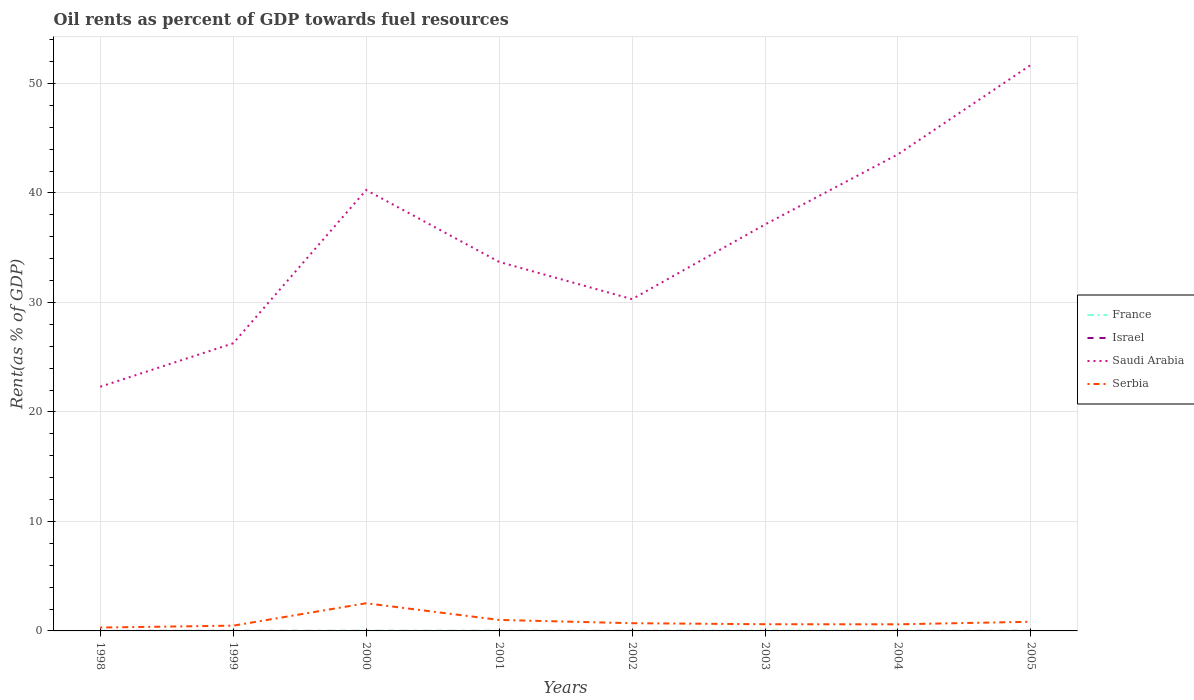Does the line corresponding to Saudi Arabia intersect with the line corresponding to Serbia?
Keep it short and to the point. No. Is the number of lines equal to the number of legend labels?
Offer a very short reply. Yes. Across all years, what is the maximum oil rent in France?
Keep it short and to the point. 0.01. In which year was the oil rent in Israel maximum?
Offer a very short reply. 2003. What is the total oil rent in Serbia in the graph?
Your answer should be compact. -0.22. What is the difference between the highest and the second highest oil rent in Serbia?
Provide a succinct answer. 2.22. Is the oil rent in Israel strictly greater than the oil rent in Saudi Arabia over the years?
Provide a short and direct response. Yes. How many years are there in the graph?
Ensure brevity in your answer.  8. Are the values on the major ticks of Y-axis written in scientific E-notation?
Provide a succinct answer. No. Does the graph contain any zero values?
Keep it short and to the point. No. Does the graph contain grids?
Offer a terse response. Yes. What is the title of the graph?
Provide a succinct answer. Oil rents as percent of GDP towards fuel resources. What is the label or title of the Y-axis?
Give a very brief answer. Rent(as % of GDP). What is the Rent(as % of GDP) in France in 1998?
Offer a terse response. 0.01. What is the Rent(as % of GDP) of Israel in 1998?
Provide a succinct answer. 0. What is the Rent(as % of GDP) in Saudi Arabia in 1998?
Offer a terse response. 22.3. What is the Rent(as % of GDP) in Serbia in 1998?
Your answer should be very brief. 0.31. What is the Rent(as % of GDP) in France in 1999?
Make the answer very short. 0.01. What is the Rent(as % of GDP) of Israel in 1999?
Give a very brief answer. 0. What is the Rent(as % of GDP) in Saudi Arabia in 1999?
Keep it short and to the point. 26.27. What is the Rent(as % of GDP) of Serbia in 1999?
Offer a very short reply. 0.48. What is the Rent(as % of GDP) of France in 2000?
Offer a very short reply. 0.02. What is the Rent(as % of GDP) of Israel in 2000?
Provide a succinct answer. 0. What is the Rent(as % of GDP) of Saudi Arabia in 2000?
Offer a very short reply. 40.27. What is the Rent(as % of GDP) of Serbia in 2000?
Keep it short and to the point. 2.53. What is the Rent(as % of GDP) in France in 2001?
Offer a terse response. 0.01. What is the Rent(as % of GDP) of Israel in 2001?
Your response must be concise. 0. What is the Rent(as % of GDP) of Saudi Arabia in 2001?
Provide a short and direct response. 33.71. What is the Rent(as % of GDP) in Serbia in 2001?
Give a very brief answer. 1. What is the Rent(as % of GDP) of France in 2002?
Provide a short and direct response. 0.01. What is the Rent(as % of GDP) in Israel in 2002?
Provide a succinct answer. 0. What is the Rent(as % of GDP) in Saudi Arabia in 2002?
Offer a very short reply. 30.3. What is the Rent(as % of GDP) in Serbia in 2002?
Ensure brevity in your answer.  0.7. What is the Rent(as % of GDP) in France in 2003?
Offer a terse response. 0.01. What is the Rent(as % of GDP) of Israel in 2003?
Give a very brief answer. 0. What is the Rent(as % of GDP) in Saudi Arabia in 2003?
Offer a terse response. 37.12. What is the Rent(as % of GDP) of Serbia in 2003?
Provide a short and direct response. 0.61. What is the Rent(as % of GDP) in France in 2004?
Ensure brevity in your answer.  0.01. What is the Rent(as % of GDP) in Israel in 2004?
Offer a very short reply. 0. What is the Rent(as % of GDP) of Saudi Arabia in 2004?
Your answer should be very brief. 43.53. What is the Rent(as % of GDP) of Serbia in 2004?
Offer a very short reply. 0.6. What is the Rent(as % of GDP) in France in 2005?
Provide a short and direct response. 0.02. What is the Rent(as % of GDP) of Israel in 2005?
Your response must be concise. 0. What is the Rent(as % of GDP) in Saudi Arabia in 2005?
Make the answer very short. 51.7. What is the Rent(as % of GDP) of Serbia in 2005?
Make the answer very short. 0.84. Across all years, what is the maximum Rent(as % of GDP) in France?
Your response must be concise. 0.02. Across all years, what is the maximum Rent(as % of GDP) in Israel?
Your response must be concise. 0. Across all years, what is the maximum Rent(as % of GDP) of Saudi Arabia?
Ensure brevity in your answer.  51.7. Across all years, what is the maximum Rent(as % of GDP) in Serbia?
Your answer should be compact. 2.53. Across all years, what is the minimum Rent(as % of GDP) in France?
Your response must be concise. 0.01. Across all years, what is the minimum Rent(as % of GDP) in Israel?
Offer a terse response. 0. Across all years, what is the minimum Rent(as % of GDP) in Saudi Arabia?
Your answer should be compact. 22.3. Across all years, what is the minimum Rent(as % of GDP) in Serbia?
Offer a terse response. 0.31. What is the total Rent(as % of GDP) in France in the graph?
Your answer should be very brief. 0.1. What is the total Rent(as % of GDP) of Israel in the graph?
Your answer should be compact. 0.01. What is the total Rent(as % of GDP) of Saudi Arabia in the graph?
Keep it short and to the point. 285.22. What is the total Rent(as % of GDP) in Serbia in the graph?
Ensure brevity in your answer.  7.08. What is the difference between the Rent(as % of GDP) of France in 1998 and that in 1999?
Your answer should be very brief. -0. What is the difference between the Rent(as % of GDP) in Israel in 1998 and that in 1999?
Your response must be concise. -0. What is the difference between the Rent(as % of GDP) in Saudi Arabia in 1998 and that in 1999?
Give a very brief answer. -3.97. What is the difference between the Rent(as % of GDP) in Serbia in 1998 and that in 1999?
Your answer should be compact. -0.17. What is the difference between the Rent(as % of GDP) in France in 1998 and that in 2000?
Give a very brief answer. -0.01. What is the difference between the Rent(as % of GDP) in Israel in 1998 and that in 2000?
Offer a terse response. 0. What is the difference between the Rent(as % of GDP) in Saudi Arabia in 1998 and that in 2000?
Ensure brevity in your answer.  -17.97. What is the difference between the Rent(as % of GDP) in Serbia in 1998 and that in 2000?
Make the answer very short. -2.22. What is the difference between the Rent(as % of GDP) of France in 1998 and that in 2001?
Keep it short and to the point. -0.01. What is the difference between the Rent(as % of GDP) in Israel in 1998 and that in 2001?
Provide a succinct answer. 0. What is the difference between the Rent(as % of GDP) of Saudi Arabia in 1998 and that in 2001?
Offer a terse response. -11.4. What is the difference between the Rent(as % of GDP) in Serbia in 1998 and that in 2001?
Provide a short and direct response. -0.69. What is the difference between the Rent(as % of GDP) of France in 1998 and that in 2002?
Make the answer very short. -0.01. What is the difference between the Rent(as % of GDP) of Israel in 1998 and that in 2002?
Offer a terse response. -0. What is the difference between the Rent(as % of GDP) of Saudi Arabia in 1998 and that in 2002?
Provide a succinct answer. -8. What is the difference between the Rent(as % of GDP) in Serbia in 1998 and that in 2002?
Keep it short and to the point. -0.39. What is the difference between the Rent(as % of GDP) of France in 1998 and that in 2003?
Offer a terse response. -0. What is the difference between the Rent(as % of GDP) in Israel in 1998 and that in 2003?
Your response must be concise. 0. What is the difference between the Rent(as % of GDP) in Saudi Arabia in 1998 and that in 2003?
Make the answer very short. -14.82. What is the difference between the Rent(as % of GDP) of Serbia in 1998 and that in 2003?
Your answer should be compact. -0.3. What is the difference between the Rent(as % of GDP) of France in 1998 and that in 2004?
Ensure brevity in your answer.  -0.01. What is the difference between the Rent(as % of GDP) in Israel in 1998 and that in 2004?
Give a very brief answer. -0. What is the difference between the Rent(as % of GDP) in Saudi Arabia in 1998 and that in 2004?
Offer a very short reply. -21.23. What is the difference between the Rent(as % of GDP) in Serbia in 1998 and that in 2004?
Keep it short and to the point. -0.29. What is the difference between the Rent(as % of GDP) in France in 1998 and that in 2005?
Provide a short and direct response. -0.01. What is the difference between the Rent(as % of GDP) of Israel in 1998 and that in 2005?
Give a very brief answer. -0. What is the difference between the Rent(as % of GDP) in Saudi Arabia in 1998 and that in 2005?
Keep it short and to the point. -29.4. What is the difference between the Rent(as % of GDP) in Serbia in 1998 and that in 2005?
Make the answer very short. -0.53. What is the difference between the Rent(as % of GDP) of France in 1999 and that in 2000?
Provide a succinct answer. -0.01. What is the difference between the Rent(as % of GDP) in Israel in 1999 and that in 2000?
Offer a terse response. 0. What is the difference between the Rent(as % of GDP) in Saudi Arabia in 1999 and that in 2000?
Make the answer very short. -14. What is the difference between the Rent(as % of GDP) of Serbia in 1999 and that in 2000?
Provide a succinct answer. -2.05. What is the difference between the Rent(as % of GDP) in France in 1999 and that in 2001?
Your answer should be compact. -0. What is the difference between the Rent(as % of GDP) of Israel in 1999 and that in 2001?
Your answer should be compact. 0. What is the difference between the Rent(as % of GDP) of Saudi Arabia in 1999 and that in 2001?
Keep it short and to the point. -7.44. What is the difference between the Rent(as % of GDP) of Serbia in 1999 and that in 2001?
Your answer should be compact. -0.52. What is the difference between the Rent(as % of GDP) in France in 1999 and that in 2002?
Give a very brief answer. -0. What is the difference between the Rent(as % of GDP) of Saudi Arabia in 1999 and that in 2002?
Your answer should be very brief. -4.03. What is the difference between the Rent(as % of GDP) in Serbia in 1999 and that in 2002?
Your response must be concise. -0.22. What is the difference between the Rent(as % of GDP) of France in 1999 and that in 2003?
Your answer should be compact. -0. What is the difference between the Rent(as % of GDP) in Israel in 1999 and that in 2003?
Your response must be concise. 0. What is the difference between the Rent(as % of GDP) of Saudi Arabia in 1999 and that in 2003?
Ensure brevity in your answer.  -10.85. What is the difference between the Rent(as % of GDP) of Serbia in 1999 and that in 2003?
Ensure brevity in your answer.  -0.13. What is the difference between the Rent(as % of GDP) in France in 1999 and that in 2004?
Provide a succinct answer. -0. What is the difference between the Rent(as % of GDP) in Saudi Arabia in 1999 and that in 2004?
Keep it short and to the point. -17.26. What is the difference between the Rent(as % of GDP) of Serbia in 1999 and that in 2004?
Ensure brevity in your answer.  -0.12. What is the difference between the Rent(as % of GDP) in France in 1999 and that in 2005?
Provide a succinct answer. -0.01. What is the difference between the Rent(as % of GDP) of Israel in 1999 and that in 2005?
Provide a succinct answer. -0. What is the difference between the Rent(as % of GDP) in Saudi Arabia in 1999 and that in 2005?
Provide a succinct answer. -25.43. What is the difference between the Rent(as % of GDP) of Serbia in 1999 and that in 2005?
Keep it short and to the point. -0.36. What is the difference between the Rent(as % of GDP) in France in 2000 and that in 2001?
Offer a terse response. 0. What is the difference between the Rent(as % of GDP) in Israel in 2000 and that in 2001?
Your answer should be very brief. 0. What is the difference between the Rent(as % of GDP) of Saudi Arabia in 2000 and that in 2001?
Ensure brevity in your answer.  6.56. What is the difference between the Rent(as % of GDP) in Serbia in 2000 and that in 2001?
Your response must be concise. 1.52. What is the difference between the Rent(as % of GDP) of France in 2000 and that in 2002?
Give a very brief answer. 0.01. What is the difference between the Rent(as % of GDP) in Israel in 2000 and that in 2002?
Ensure brevity in your answer.  -0. What is the difference between the Rent(as % of GDP) of Saudi Arabia in 2000 and that in 2002?
Offer a terse response. 9.97. What is the difference between the Rent(as % of GDP) of Serbia in 2000 and that in 2002?
Your answer should be very brief. 1.82. What is the difference between the Rent(as % of GDP) in France in 2000 and that in 2003?
Give a very brief answer. 0.01. What is the difference between the Rent(as % of GDP) in Saudi Arabia in 2000 and that in 2003?
Your answer should be very brief. 3.15. What is the difference between the Rent(as % of GDP) of Serbia in 2000 and that in 2003?
Ensure brevity in your answer.  1.92. What is the difference between the Rent(as % of GDP) of France in 2000 and that in 2004?
Your answer should be compact. 0.01. What is the difference between the Rent(as % of GDP) in Israel in 2000 and that in 2004?
Your response must be concise. -0. What is the difference between the Rent(as % of GDP) of Saudi Arabia in 2000 and that in 2004?
Provide a short and direct response. -3.26. What is the difference between the Rent(as % of GDP) in Serbia in 2000 and that in 2004?
Your answer should be very brief. 1.92. What is the difference between the Rent(as % of GDP) of France in 2000 and that in 2005?
Provide a succinct answer. 0. What is the difference between the Rent(as % of GDP) of Israel in 2000 and that in 2005?
Your answer should be compact. -0. What is the difference between the Rent(as % of GDP) of Saudi Arabia in 2000 and that in 2005?
Provide a short and direct response. -11.43. What is the difference between the Rent(as % of GDP) in Serbia in 2000 and that in 2005?
Give a very brief answer. 1.69. What is the difference between the Rent(as % of GDP) in France in 2001 and that in 2002?
Offer a terse response. 0. What is the difference between the Rent(as % of GDP) in Israel in 2001 and that in 2002?
Keep it short and to the point. -0. What is the difference between the Rent(as % of GDP) of Saudi Arabia in 2001 and that in 2002?
Offer a very short reply. 3.4. What is the difference between the Rent(as % of GDP) of Serbia in 2001 and that in 2002?
Make the answer very short. 0.3. What is the difference between the Rent(as % of GDP) of France in 2001 and that in 2003?
Offer a very short reply. 0. What is the difference between the Rent(as % of GDP) of Israel in 2001 and that in 2003?
Offer a very short reply. 0. What is the difference between the Rent(as % of GDP) of Saudi Arabia in 2001 and that in 2003?
Keep it short and to the point. -3.42. What is the difference between the Rent(as % of GDP) in Serbia in 2001 and that in 2003?
Provide a succinct answer. 0.39. What is the difference between the Rent(as % of GDP) of France in 2001 and that in 2004?
Make the answer very short. 0. What is the difference between the Rent(as % of GDP) in Israel in 2001 and that in 2004?
Your answer should be very brief. -0. What is the difference between the Rent(as % of GDP) in Saudi Arabia in 2001 and that in 2004?
Make the answer very short. -9.83. What is the difference between the Rent(as % of GDP) in Serbia in 2001 and that in 2004?
Give a very brief answer. 0.4. What is the difference between the Rent(as % of GDP) in France in 2001 and that in 2005?
Your answer should be compact. -0. What is the difference between the Rent(as % of GDP) of Israel in 2001 and that in 2005?
Provide a succinct answer. -0. What is the difference between the Rent(as % of GDP) of Saudi Arabia in 2001 and that in 2005?
Provide a short and direct response. -17.99. What is the difference between the Rent(as % of GDP) of Serbia in 2001 and that in 2005?
Your answer should be very brief. 0.17. What is the difference between the Rent(as % of GDP) in France in 2002 and that in 2003?
Give a very brief answer. 0. What is the difference between the Rent(as % of GDP) in Israel in 2002 and that in 2003?
Provide a short and direct response. 0. What is the difference between the Rent(as % of GDP) in Saudi Arabia in 2002 and that in 2003?
Your answer should be very brief. -6.82. What is the difference between the Rent(as % of GDP) of Serbia in 2002 and that in 2003?
Give a very brief answer. 0.09. What is the difference between the Rent(as % of GDP) of France in 2002 and that in 2004?
Keep it short and to the point. -0. What is the difference between the Rent(as % of GDP) in Israel in 2002 and that in 2004?
Keep it short and to the point. -0. What is the difference between the Rent(as % of GDP) in Saudi Arabia in 2002 and that in 2004?
Your response must be concise. -13.23. What is the difference between the Rent(as % of GDP) in Serbia in 2002 and that in 2004?
Offer a terse response. 0.1. What is the difference between the Rent(as % of GDP) in France in 2002 and that in 2005?
Provide a succinct answer. -0. What is the difference between the Rent(as % of GDP) in Israel in 2002 and that in 2005?
Give a very brief answer. -0. What is the difference between the Rent(as % of GDP) of Saudi Arabia in 2002 and that in 2005?
Give a very brief answer. -21.4. What is the difference between the Rent(as % of GDP) in Serbia in 2002 and that in 2005?
Your response must be concise. -0.13. What is the difference between the Rent(as % of GDP) in France in 2003 and that in 2004?
Make the answer very short. -0. What is the difference between the Rent(as % of GDP) of Israel in 2003 and that in 2004?
Keep it short and to the point. -0. What is the difference between the Rent(as % of GDP) in Saudi Arabia in 2003 and that in 2004?
Provide a short and direct response. -6.41. What is the difference between the Rent(as % of GDP) of Serbia in 2003 and that in 2004?
Your answer should be compact. 0.01. What is the difference between the Rent(as % of GDP) in France in 2003 and that in 2005?
Offer a very short reply. -0.01. What is the difference between the Rent(as % of GDP) of Israel in 2003 and that in 2005?
Ensure brevity in your answer.  -0. What is the difference between the Rent(as % of GDP) in Saudi Arabia in 2003 and that in 2005?
Ensure brevity in your answer.  -14.58. What is the difference between the Rent(as % of GDP) of Serbia in 2003 and that in 2005?
Provide a succinct answer. -0.22. What is the difference between the Rent(as % of GDP) in France in 2004 and that in 2005?
Provide a succinct answer. -0. What is the difference between the Rent(as % of GDP) of Israel in 2004 and that in 2005?
Offer a very short reply. -0. What is the difference between the Rent(as % of GDP) of Saudi Arabia in 2004 and that in 2005?
Keep it short and to the point. -8.17. What is the difference between the Rent(as % of GDP) in Serbia in 2004 and that in 2005?
Your response must be concise. -0.23. What is the difference between the Rent(as % of GDP) in France in 1998 and the Rent(as % of GDP) in Israel in 1999?
Give a very brief answer. 0.01. What is the difference between the Rent(as % of GDP) of France in 1998 and the Rent(as % of GDP) of Saudi Arabia in 1999?
Offer a terse response. -26.26. What is the difference between the Rent(as % of GDP) in France in 1998 and the Rent(as % of GDP) in Serbia in 1999?
Offer a terse response. -0.47. What is the difference between the Rent(as % of GDP) of Israel in 1998 and the Rent(as % of GDP) of Saudi Arabia in 1999?
Offer a terse response. -26.27. What is the difference between the Rent(as % of GDP) in Israel in 1998 and the Rent(as % of GDP) in Serbia in 1999?
Ensure brevity in your answer.  -0.48. What is the difference between the Rent(as % of GDP) of Saudi Arabia in 1998 and the Rent(as % of GDP) of Serbia in 1999?
Ensure brevity in your answer.  21.82. What is the difference between the Rent(as % of GDP) in France in 1998 and the Rent(as % of GDP) in Israel in 2000?
Offer a terse response. 0.01. What is the difference between the Rent(as % of GDP) of France in 1998 and the Rent(as % of GDP) of Saudi Arabia in 2000?
Provide a short and direct response. -40.27. What is the difference between the Rent(as % of GDP) of France in 1998 and the Rent(as % of GDP) of Serbia in 2000?
Your answer should be very brief. -2.52. What is the difference between the Rent(as % of GDP) in Israel in 1998 and the Rent(as % of GDP) in Saudi Arabia in 2000?
Provide a succinct answer. -40.27. What is the difference between the Rent(as % of GDP) in Israel in 1998 and the Rent(as % of GDP) in Serbia in 2000?
Offer a very short reply. -2.53. What is the difference between the Rent(as % of GDP) of Saudi Arabia in 1998 and the Rent(as % of GDP) of Serbia in 2000?
Offer a very short reply. 19.78. What is the difference between the Rent(as % of GDP) of France in 1998 and the Rent(as % of GDP) of Israel in 2001?
Ensure brevity in your answer.  0.01. What is the difference between the Rent(as % of GDP) in France in 1998 and the Rent(as % of GDP) in Saudi Arabia in 2001?
Provide a short and direct response. -33.7. What is the difference between the Rent(as % of GDP) of France in 1998 and the Rent(as % of GDP) of Serbia in 2001?
Offer a very short reply. -1. What is the difference between the Rent(as % of GDP) in Israel in 1998 and the Rent(as % of GDP) in Saudi Arabia in 2001?
Your answer should be very brief. -33.71. What is the difference between the Rent(as % of GDP) of Israel in 1998 and the Rent(as % of GDP) of Serbia in 2001?
Your answer should be compact. -1. What is the difference between the Rent(as % of GDP) in Saudi Arabia in 1998 and the Rent(as % of GDP) in Serbia in 2001?
Provide a short and direct response. 21.3. What is the difference between the Rent(as % of GDP) in France in 1998 and the Rent(as % of GDP) in Israel in 2002?
Your response must be concise. 0.01. What is the difference between the Rent(as % of GDP) of France in 1998 and the Rent(as % of GDP) of Saudi Arabia in 2002?
Offer a very short reply. -30.3. What is the difference between the Rent(as % of GDP) of France in 1998 and the Rent(as % of GDP) of Serbia in 2002?
Make the answer very short. -0.7. What is the difference between the Rent(as % of GDP) in Israel in 1998 and the Rent(as % of GDP) in Saudi Arabia in 2002?
Give a very brief answer. -30.3. What is the difference between the Rent(as % of GDP) in Israel in 1998 and the Rent(as % of GDP) in Serbia in 2002?
Keep it short and to the point. -0.7. What is the difference between the Rent(as % of GDP) in Saudi Arabia in 1998 and the Rent(as % of GDP) in Serbia in 2002?
Keep it short and to the point. 21.6. What is the difference between the Rent(as % of GDP) of France in 1998 and the Rent(as % of GDP) of Israel in 2003?
Your answer should be very brief. 0.01. What is the difference between the Rent(as % of GDP) in France in 1998 and the Rent(as % of GDP) in Saudi Arabia in 2003?
Ensure brevity in your answer.  -37.12. What is the difference between the Rent(as % of GDP) of France in 1998 and the Rent(as % of GDP) of Serbia in 2003?
Offer a terse response. -0.6. What is the difference between the Rent(as % of GDP) in Israel in 1998 and the Rent(as % of GDP) in Saudi Arabia in 2003?
Your answer should be very brief. -37.12. What is the difference between the Rent(as % of GDP) of Israel in 1998 and the Rent(as % of GDP) of Serbia in 2003?
Make the answer very short. -0.61. What is the difference between the Rent(as % of GDP) of Saudi Arabia in 1998 and the Rent(as % of GDP) of Serbia in 2003?
Offer a terse response. 21.69. What is the difference between the Rent(as % of GDP) of France in 1998 and the Rent(as % of GDP) of Israel in 2004?
Keep it short and to the point. 0.01. What is the difference between the Rent(as % of GDP) in France in 1998 and the Rent(as % of GDP) in Saudi Arabia in 2004?
Keep it short and to the point. -43.53. What is the difference between the Rent(as % of GDP) in France in 1998 and the Rent(as % of GDP) in Serbia in 2004?
Offer a very short reply. -0.6. What is the difference between the Rent(as % of GDP) in Israel in 1998 and the Rent(as % of GDP) in Saudi Arabia in 2004?
Your response must be concise. -43.53. What is the difference between the Rent(as % of GDP) in Israel in 1998 and the Rent(as % of GDP) in Serbia in 2004?
Ensure brevity in your answer.  -0.6. What is the difference between the Rent(as % of GDP) of Saudi Arabia in 1998 and the Rent(as % of GDP) of Serbia in 2004?
Provide a short and direct response. 21.7. What is the difference between the Rent(as % of GDP) of France in 1998 and the Rent(as % of GDP) of Israel in 2005?
Offer a very short reply. 0.01. What is the difference between the Rent(as % of GDP) in France in 1998 and the Rent(as % of GDP) in Saudi Arabia in 2005?
Offer a terse response. -51.69. What is the difference between the Rent(as % of GDP) of France in 1998 and the Rent(as % of GDP) of Serbia in 2005?
Provide a succinct answer. -0.83. What is the difference between the Rent(as % of GDP) of Israel in 1998 and the Rent(as % of GDP) of Saudi Arabia in 2005?
Your response must be concise. -51.7. What is the difference between the Rent(as % of GDP) of Israel in 1998 and the Rent(as % of GDP) of Serbia in 2005?
Keep it short and to the point. -0.84. What is the difference between the Rent(as % of GDP) in Saudi Arabia in 1998 and the Rent(as % of GDP) in Serbia in 2005?
Provide a short and direct response. 21.47. What is the difference between the Rent(as % of GDP) of France in 1999 and the Rent(as % of GDP) of Israel in 2000?
Keep it short and to the point. 0.01. What is the difference between the Rent(as % of GDP) in France in 1999 and the Rent(as % of GDP) in Saudi Arabia in 2000?
Your response must be concise. -40.26. What is the difference between the Rent(as % of GDP) in France in 1999 and the Rent(as % of GDP) in Serbia in 2000?
Offer a very short reply. -2.52. What is the difference between the Rent(as % of GDP) of Israel in 1999 and the Rent(as % of GDP) of Saudi Arabia in 2000?
Your answer should be very brief. -40.27. What is the difference between the Rent(as % of GDP) of Israel in 1999 and the Rent(as % of GDP) of Serbia in 2000?
Make the answer very short. -2.53. What is the difference between the Rent(as % of GDP) in Saudi Arabia in 1999 and the Rent(as % of GDP) in Serbia in 2000?
Your answer should be very brief. 23.74. What is the difference between the Rent(as % of GDP) in France in 1999 and the Rent(as % of GDP) in Israel in 2001?
Your response must be concise. 0.01. What is the difference between the Rent(as % of GDP) of France in 1999 and the Rent(as % of GDP) of Saudi Arabia in 2001?
Ensure brevity in your answer.  -33.7. What is the difference between the Rent(as % of GDP) of France in 1999 and the Rent(as % of GDP) of Serbia in 2001?
Your answer should be very brief. -0.99. What is the difference between the Rent(as % of GDP) of Israel in 1999 and the Rent(as % of GDP) of Saudi Arabia in 2001?
Provide a succinct answer. -33.71. What is the difference between the Rent(as % of GDP) in Israel in 1999 and the Rent(as % of GDP) in Serbia in 2001?
Ensure brevity in your answer.  -1. What is the difference between the Rent(as % of GDP) in Saudi Arabia in 1999 and the Rent(as % of GDP) in Serbia in 2001?
Ensure brevity in your answer.  25.27. What is the difference between the Rent(as % of GDP) in France in 1999 and the Rent(as % of GDP) in Israel in 2002?
Provide a short and direct response. 0.01. What is the difference between the Rent(as % of GDP) of France in 1999 and the Rent(as % of GDP) of Saudi Arabia in 2002?
Offer a terse response. -30.29. What is the difference between the Rent(as % of GDP) of France in 1999 and the Rent(as % of GDP) of Serbia in 2002?
Keep it short and to the point. -0.69. What is the difference between the Rent(as % of GDP) in Israel in 1999 and the Rent(as % of GDP) in Saudi Arabia in 2002?
Make the answer very short. -30.3. What is the difference between the Rent(as % of GDP) of Israel in 1999 and the Rent(as % of GDP) of Serbia in 2002?
Offer a terse response. -0.7. What is the difference between the Rent(as % of GDP) in Saudi Arabia in 1999 and the Rent(as % of GDP) in Serbia in 2002?
Make the answer very short. 25.57. What is the difference between the Rent(as % of GDP) in France in 1999 and the Rent(as % of GDP) in Israel in 2003?
Your answer should be compact. 0.01. What is the difference between the Rent(as % of GDP) in France in 1999 and the Rent(as % of GDP) in Saudi Arabia in 2003?
Your answer should be compact. -37.11. What is the difference between the Rent(as % of GDP) of France in 1999 and the Rent(as % of GDP) of Serbia in 2003?
Your answer should be compact. -0.6. What is the difference between the Rent(as % of GDP) of Israel in 1999 and the Rent(as % of GDP) of Saudi Arabia in 2003?
Provide a short and direct response. -37.12. What is the difference between the Rent(as % of GDP) in Israel in 1999 and the Rent(as % of GDP) in Serbia in 2003?
Ensure brevity in your answer.  -0.61. What is the difference between the Rent(as % of GDP) of Saudi Arabia in 1999 and the Rent(as % of GDP) of Serbia in 2003?
Provide a short and direct response. 25.66. What is the difference between the Rent(as % of GDP) of France in 1999 and the Rent(as % of GDP) of Israel in 2004?
Make the answer very short. 0.01. What is the difference between the Rent(as % of GDP) in France in 1999 and the Rent(as % of GDP) in Saudi Arabia in 2004?
Offer a terse response. -43.52. What is the difference between the Rent(as % of GDP) in France in 1999 and the Rent(as % of GDP) in Serbia in 2004?
Ensure brevity in your answer.  -0.59. What is the difference between the Rent(as % of GDP) of Israel in 1999 and the Rent(as % of GDP) of Saudi Arabia in 2004?
Keep it short and to the point. -43.53. What is the difference between the Rent(as % of GDP) of Israel in 1999 and the Rent(as % of GDP) of Serbia in 2004?
Offer a terse response. -0.6. What is the difference between the Rent(as % of GDP) in Saudi Arabia in 1999 and the Rent(as % of GDP) in Serbia in 2004?
Make the answer very short. 25.67. What is the difference between the Rent(as % of GDP) in France in 1999 and the Rent(as % of GDP) in Israel in 2005?
Provide a succinct answer. 0.01. What is the difference between the Rent(as % of GDP) in France in 1999 and the Rent(as % of GDP) in Saudi Arabia in 2005?
Your answer should be compact. -51.69. What is the difference between the Rent(as % of GDP) of France in 1999 and the Rent(as % of GDP) of Serbia in 2005?
Offer a terse response. -0.83. What is the difference between the Rent(as % of GDP) of Israel in 1999 and the Rent(as % of GDP) of Saudi Arabia in 2005?
Provide a succinct answer. -51.7. What is the difference between the Rent(as % of GDP) in Israel in 1999 and the Rent(as % of GDP) in Serbia in 2005?
Offer a very short reply. -0.84. What is the difference between the Rent(as % of GDP) in Saudi Arabia in 1999 and the Rent(as % of GDP) in Serbia in 2005?
Make the answer very short. 25.44. What is the difference between the Rent(as % of GDP) in France in 2000 and the Rent(as % of GDP) in Israel in 2001?
Offer a very short reply. 0.02. What is the difference between the Rent(as % of GDP) in France in 2000 and the Rent(as % of GDP) in Saudi Arabia in 2001?
Offer a terse response. -33.69. What is the difference between the Rent(as % of GDP) in France in 2000 and the Rent(as % of GDP) in Serbia in 2001?
Make the answer very short. -0.99. What is the difference between the Rent(as % of GDP) of Israel in 2000 and the Rent(as % of GDP) of Saudi Arabia in 2001?
Provide a succinct answer. -33.71. What is the difference between the Rent(as % of GDP) in Israel in 2000 and the Rent(as % of GDP) in Serbia in 2001?
Your answer should be compact. -1. What is the difference between the Rent(as % of GDP) of Saudi Arabia in 2000 and the Rent(as % of GDP) of Serbia in 2001?
Your answer should be very brief. 39.27. What is the difference between the Rent(as % of GDP) in France in 2000 and the Rent(as % of GDP) in Israel in 2002?
Ensure brevity in your answer.  0.02. What is the difference between the Rent(as % of GDP) of France in 2000 and the Rent(as % of GDP) of Saudi Arabia in 2002?
Give a very brief answer. -30.29. What is the difference between the Rent(as % of GDP) of France in 2000 and the Rent(as % of GDP) of Serbia in 2002?
Make the answer very short. -0.69. What is the difference between the Rent(as % of GDP) in Israel in 2000 and the Rent(as % of GDP) in Saudi Arabia in 2002?
Ensure brevity in your answer.  -30.3. What is the difference between the Rent(as % of GDP) of Israel in 2000 and the Rent(as % of GDP) of Serbia in 2002?
Ensure brevity in your answer.  -0.7. What is the difference between the Rent(as % of GDP) in Saudi Arabia in 2000 and the Rent(as % of GDP) in Serbia in 2002?
Ensure brevity in your answer.  39.57. What is the difference between the Rent(as % of GDP) of France in 2000 and the Rent(as % of GDP) of Israel in 2003?
Ensure brevity in your answer.  0.02. What is the difference between the Rent(as % of GDP) of France in 2000 and the Rent(as % of GDP) of Saudi Arabia in 2003?
Provide a short and direct response. -37.11. What is the difference between the Rent(as % of GDP) of France in 2000 and the Rent(as % of GDP) of Serbia in 2003?
Keep it short and to the point. -0.59. What is the difference between the Rent(as % of GDP) of Israel in 2000 and the Rent(as % of GDP) of Saudi Arabia in 2003?
Provide a succinct answer. -37.12. What is the difference between the Rent(as % of GDP) in Israel in 2000 and the Rent(as % of GDP) in Serbia in 2003?
Your answer should be compact. -0.61. What is the difference between the Rent(as % of GDP) of Saudi Arabia in 2000 and the Rent(as % of GDP) of Serbia in 2003?
Make the answer very short. 39.66. What is the difference between the Rent(as % of GDP) in France in 2000 and the Rent(as % of GDP) in Israel in 2004?
Keep it short and to the point. 0.02. What is the difference between the Rent(as % of GDP) in France in 2000 and the Rent(as % of GDP) in Saudi Arabia in 2004?
Offer a very short reply. -43.52. What is the difference between the Rent(as % of GDP) of France in 2000 and the Rent(as % of GDP) of Serbia in 2004?
Your answer should be compact. -0.59. What is the difference between the Rent(as % of GDP) in Israel in 2000 and the Rent(as % of GDP) in Saudi Arabia in 2004?
Offer a very short reply. -43.53. What is the difference between the Rent(as % of GDP) of Israel in 2000 and the Rent(as % of GDP) of Serbia in 2004?
Keep it short and to the point. -0.6. What is the difference between the Rent(as % of GDP) of Saudi Arabia in 2000 and the Rent(as % of GDP) of Serbia in 2004?
Ensure brevity in your answer.  39.67. What is the difference between the Rent(as % of GDP) of France in 2000 and the Rent(as % of GDP) of Israel in 2005?
Your answer should be compact. 0.02. What is the difference between the Rent(as % of GDP) of France in 2000 and the Rent(as % of GDP) of Saudi Arabia in 2005?
Make the answer very short. -51.68. What is the difference between the Rent(as % of GDP) in France in 2000 and the Rent(as % of GDP) in Serbia in 2005?
Offer a very short reply. -0.82. What is the difference between the Rent(as % of GDP) in Israel in 2000 and the Rent(as % of GDP) in Saudi Arabia in 2005?
Ensure brevity in your answer.  -51.7. What is the difference between the Rent(as % of GDP) of Israel in 2000 and the Rent(as % of GDP) of Serbia in 2005?
Provide a short and direct response. -0.84. What is the difference between the Rent(as % of GDP) of Saudi Arabia in 2000 and the Rent(as % of GDP) of Serbia in 2005?
Give a very brief answer. 39.44. What is the difference between the Rent(as % of GDP) of France in 2001 and the Rent(as % of GDP) of Israel in 2002?
Your answer should be compact. 0.01. What is the difference between the Rent(as % of GDP) of France in 2001 and the Rent(as % of GDP) of Saudi Arabia in 2002?
Keep it short and to the point. -30.29. What is the difference between the Rent(as % of GDP) of France in 2001 and the Rent(as % of GDP) of Serbia in 2002?
Keep it short and to the point. -0.69. What is the difference between the Rent(as % of GDP) in Israel in 2001 and the Rent(as % of GDP) in Saudi Arabia in 2002?
Provide a short and direct response. -30.3. What is the difference between the Rent(as % of GDP) of Israel in 2001 and the Rent(as % of GDP) of Serbia in 2002?
Provide a succinct answer. -0.7. What is the difference between the Rent(as % of GDP) of Saudi Arabia in 2001 and the Rent(as % of GDP) of Serbia in 2002?
Give a very brief answer. 33. What is the difference between the Rent(as % of GDP) in France in 2001 and the Rent(as % of GDP) in Israel in 2003?
Your answer should be very brief. 0.01. What is the difference between the Rent(as % of GDP) in France in 2001 and the Rent(as % of GDP) in Saudi Arabia in 2003?
Your answer should be very brief. -37.11. What is the difference between the Rent(as % of GDP) of France in 2001 and the Rent(as % of GDP) of Serbia in 2003?
Give a very brief answer. -0.6. What is the difference between the Rent(as % of GDP) of Israel in 2001 and the Rent(as % of GDP) of Saudi Arabia in 2003?
Provide a short and direct response. -37.12. What is the difference between the Rent(as % of GDP) of Israel in 2001 and the Rent(as % of GDP) of Serbia in 2003?
Ensure brevity in your answer.  -0.61. What is the difference between the Rent(as % of GDP) of Saudi Arabia in 2001 and the Rent(as % of GDP) of Serbia in 2003?
Provide a succinct answer. 33.1. What is the difference between the Rent(as % of GDP) in France in 2001 and the Rent(as % of GDP) in Israel in 2004?
Ensure brevity in your answer.  0.01. What is the difference between the Rent(as % of GDP) in France in 2001 and the Rent(as % of GDP) in Saudi Arabia in 2004?
Keep it short and to the point. -43.52. What is the difference between the Rent(as % of GDP) of France in 2001 and the Rent(as % of GDP) of Serbia in 2004?
Your answer should be compact. -0.59. What is the difference between the Rent(as % of GDP) of Israel in 2001 and the Rent(as % of GDP) of Saudi Arabia in 2004?
Provide a short and direct response. -43.53. What is the difference between the Rent(as % of GDP) in Israel in 2001 and the Rent(as % of GDP) in Serbia in 2004?
Your answer should be compact. -0.6. What is the difference between the Rent(as % of GDP) in Saudi Arabia in 2001 and the Rent(as % of GDP) in Serbia in 2004?
Make the answer very short. 33.1. What is the difference between the Rent(as % of GDP) in France in 2001 and the Rent(as % of GDP) in Israel in 2005?
Make the answer very short. 0.01. What is the difference between the Rent(as % of GDP) of France in 2001 and the Rent(as % of GDP) of Saudi Arabia in 2005?
Offer a terse response. -51.69. What is the difference between the Rent(as % of GDP) of France in 2001 and the Rent(as % of GDP) of Serbia in 2005?
Make the answer very short. -0.82. What is the difference between the Rent(as % of GDP) of Israel in 2001 and the Rent(as % of GDP) of Saudi Arabia in 2005?
Make the answer very short. -51.7. What is the difference between the Rent(as % of GDP) in Israel in 2001 and the Rent(as % of GDP) in Serbia in 2005?
Offer a terse response. -0.84. What is the difference between the Rent(as % of GDP) of Saudi Arabia in 2001 and the Rent(as % of GDP) of Serbia in 2005?
Offer a terse response. 32.87. What is the difference between the Rent(as % of GDP) of France in 2002 and the Rent(as % of GDP) of Israel in 2003?
Your answer should be very brief. 0.01. What is the difference between the Rent(as % of GDP) in France in 2002 and the Rent(as % of GDP) in Saudi Arabia in 2003?
Give a very brief answer. -37.11. What is the difference between the Rent(as % of GDP) of France in 2002 and the Rent(as % of GDP) of Serbia in 2003?
Your answer should be compact. -0.6. What is the difference between the Rent(as % of GDP) in Israel in 2002 and the Rent(as % of GDP) in Saudi Arabia in 2003?
Ensure brevity in your answer.  -37.12. What is the difference between the Rent(as % of GDP) of Israel in 2002 and the Rent(as % of GDP) of Serbia in 2003?
Your answer should be compact. -0.61. What is the difference between the Rent(as % of GDP) of Saudi Arabia in 2002 and the Rent(as % of GDP) of Serbia in 2003?
Offer a terse response. 29.69. What is the difference between the Rent(as % of GDP) of France in 2002 and the Rent(as % of GDP) of Israel in 2004?
Your response must be concise. 0.01. What is the difference between the Rent(as % of GDP) of France in 2002 and the Rent(as % of GDP) of Saudi Arabia in 2004?
Give a very brief answer. -43.52. What is the difference between the Rent(as % of GDP) of France in 2002 and the Rent(as % of GDP) of Serbia in 2004?
Ensure brevity in your answer.  -0.59. What is the difference between the Rent(as % of GDP) in Israel in 2002 and the Rent(as % of GDP) in Saudi Arabia in 2004?
Give a very brief answer. -43.53. What is the difference between the Rent(as % of GDP) of Israel in 2002 and the Rent(as % of GDP) of Serbia in 2004?
Ensure brevity in your answer.  -0.6. What is the difference between the Rent(as % of GDP) of Saudi Arabia in 2002 and the Rent(as % of GDP) of Serbia in 2004?
Offer a terse response. 29.7. What is the difference between the Rent(as % of GDP) in France in 2002 and the Rent(as % of GDP) in Israel in 2005?
Your answer should be very brief. 0.01. What is the difference between the Rent(as % of GDP) of France in 2002 and the Rent(as % of GDP) of Saudi Arabia in 2005?
Ensure brevity in your answer.  -51.69. What is the difference between the Rent(as % of GDP) in France in 2002 and the Rent(as % of GDP) in Serbia in 2005?
Keep it short and to the point. -0.82. What is the difference between the Rent(as % of GDP) in Israel in 2002 and the Rent(as % of GDP) in Saudi Arabia in 2005?
Your answer should be very brief. -51.7. What is the difference between the Rent(as % of GDP) in Israel in 2002 and the Rent(as % of GDP) in Serbia in 2005?
Keep it short and to the point. -0.84. What is the difference between the Rent(as % of GDP) in Saudi Arabia in 2002 and the Rent(as % of GDP) in Serbia in 2005?
Your response must be concise. 29.47. What is the difference between the Rent(as % of GDP) in France in 2003 and the Rent(as % of GDP) in Israel in 2004?
Your response must be concise. 0.01. What is the difference between the Rent(as % of GDP) of France in 2003 and the Rent(as % of GDP) of Saudi Arabia in 2004?
Provide a succinct answer. -43.52. What is the difference between the Rent(as % of GDP) in France in 2003 and the Rent(as % of GDP) in Serbia in 2004?
Give a very brief answer. -0.59. What is the difference between the Rent(as % of GDP) in Israel in 2003 and the Rent(as % of GDP) in Saudi Arabia in 2004?
Provide a succinct answer. -43.53. What is the difference between the Rent(as % of GDP) in Israel in 2003 and the Rent(as % of GDP) in Serbia in 2004?
Your response must be concise. -0.6. What is the difference between the Rent(as % of GDP) in Saudi Arabia in 2003 and the Rent(as % of GDP) in Serbia in 2004?
Your answer should be very brief. 36.52. What is the difference between the Rent(as % of GDP) of France in 2003 and the Rent(as % of GDP) of Israel in 2005?
Your response must be concise. 0.01. What is the difference between the Rent(as % of GDP) in France in 2003 and the Rent(as % of GDP) in Saudi Arabia in 2005?
Provide a short and direct response. -51.69. What is the difference between the Rent(as % of GDP) of France in 2003 and the Rent(as % of GDP) of Serbia in 2005?
Ensure brevity in your answer.  -0.83. What is the difference between the Rent(as % of GDP) of Israel in 2003 and the Rent(as % of GDP) of Saudi Arabia in 2005?
Your answer should be very brief. -51.7. What is the difference between the Rent(as % of GDP) of Israel in 2003 and the Rent(as % of GDP) of Serbia in 2005?
Your response must be concise. -0.84. What is the difference between the Rent(as % of GDP) of Saudi Arabia in 2003 and the Rent(as % of GDP) of Serbia in 2005?
Give a very brief answer. 36.29. What is the difference between the Rent(as % of GDP) in France in 2004 and the Rent(as % of GDP) in Israel in 2005?
Your response must be concise. 0.01. What is the difference between the Rent(as % of GDP) in France in 2004 and the Rent(as % of GDP) in Saudi Arabia in 2005?
Your response must be concise. -51.69. What is the difference between the Rent(as % of GDP) in France in 2004 and the Rent(as % of GDP) in Serbia in 2005?
Your answer should be very brief. -0.82. What is the difference between the Rent(as % of GDP) of Israel in 2004 and the Rent(as % of GDP) of Saudi Arabia in 2005?
Provide a short and direct response. -51.7. What is the difference between the Rent(as % of GDP) of Israel in 2004 and the Rent(as % of GDP) of Serbia in 2005?
Your response must be concise. -0.84. What is the difference between the Rent(as % of GDP) of Saudi Arabia in 2004 and the Rent(as % of GDP) of Serbia in 2005?
Your response must be concise. 42.7. What is the average Rent(as % of GDP) of France per year?
Keep it short and to the point. 0.01. What is the average Rent(as % of GDP) of Israel per year?
Offer a terse response. 0. What is the average Rent(as % of GDP) in Saudi Arabia per year?
Offer a terse response. 35.65. What is the average Rent(as % of GDP) of Serbia per year?
Give a very brief answer. 0.88. In the year 1998, what is the difference between the Rent(as % of GDP) in France and Rent(as % of GDP) in Israel?
Keep it short and to the point. 0.01. In the year 1998, what is the difference between the Rent(as % of GDP) of France and Rent(as % of GDP) of Saudi Arabia?
Offer a very short reply. -22.3. In the year 1998, what is the difference between the Rent(as % of GDP) of France and Rent(as % of GDP) of Serbia?
Your answer should be very brief. -0.3. In the year 1998, what is the difference between the Rent(as % of GDP) of Israel and Rent(as % of GDP) of Saudi Arabia?
Provide a succinct answer. -22.3. In the year 1998, what is the difference between the Rent(as % of GDP) in Israel and Rent(as % of GDP) in Serbia?
Your answer should be compact. -0.31. In the year 1998, what is the difference between the Rent(as % of GDP) in Saudi Arabia and Rent(as % of GDP) in Serbia?
Provide a succinct answer. 21.99. In the year 1999, what is the difference between the Rent(as % of GDP) of France and Rent(as % of GDP) of Israel?
Ensure brevity in your answer.  0.01. In the year 1999, what is the difference between the Rent(as % of GDP) in France and Rent(as % of GDP) in Saudi Arabia?
Ensure brevity in your answer.  -26.26. In the year 1999, what is the difference between the Rent(as % of GDP) of France and Rent(as % of GDP) of Serbia?
Your answer should be compact. -0.47. In the year 1999, what is the difference between the Rent(as % of GDP) of Israel and Rent(as % of GDP) of Saudi Arabia?
Your answer should be compact. -26.27. In the year 1999, what is the difference between the Rent(as % of GDP) in Israel and Rent(as % of GDP) in Serbia?
Your answer should be very brief. -0.48. In the year 1999, what is the difference between the Rent(as % of GDP) of Saudi Arabia and Rent(as % of GDP) of Serbia?
Make the answer very short. 25.79. In the year 2000, what is the difference between the Rent(as % of GDP) of France and Rent(as % of GDP) of Israel?
Offer a terse response. 0.02. In the year 2000, what is the difference between the Rent(as % of GDP) of France and Rent(as % of GDP) of Saudi Arabia?
Offer a very short reply. -40.26. In the year 2000, what is the difference between the Rent(as % of GDP) in France and Rent(as % of GDP) in Serbia?
Your response must be concise. -2.51. In the year 2000, what is the difference between the Rent(as % of GDP) in Israel and Rent(as % of GDP) in Saudi Arabia?
Keep it short and to the point. -40.27. In the year 2000, what is the difference between the Rent(as % of GDP) in Israel and Rent(as % of GDP) in Serbia?
Provide a succinct answer. -2.53. In the year 2000, what is the difference between the Rent(as % of GDP) of Saudi Arabia and Rent(as % of GDP) of Serbia?
Offer a terse response. 37.74. In the year 2001, what is the difference between the Rent(as % of GDP) in France and Rent(as % of GDP) in Israel?
Your answer should be compact. 0.01. In the year 2001, what is the difference between the Rent(as % of GDP) in France and Rent(as % of GDP) in Saudi Arabia?
Offer a terse response. -33.69. In the year 2001, what is the difference between the Rent(as % of GDP) in France and Rent(as % of GDP) in Serbia?
Offer a very short reply. -0.99. In the year 2001, what is the difference between the Rent(as % of GDP) of Israel and Rent(as % of GDP) of Saudi Arabia?
Offer a terse response. -33.71. In the year 2001, what is the difference between the Rent(as % of GDP) in Israel and Rent(as % of GDP) in Serbia?
Your answer should be very brief. -1. In the year 2001, what is the difference between the Rent(as % of GDP) of Saudi Arabia and Rent(as % of GDP) of Serbia?
Offer a very short reply. 32.7. In the year 2002, what is the difference between the Rent(as % of GDP) in France and Rent(as % of GDP) in Israel?
Keep it short and to the point. 0.01. In the year 2002, what is the difference between the Rent(as % of GDP) in France and Rent(as % of GDP) in Saudi Arabia?
Keep it short and to the point. -30.29. In the year 2002, what is the difference between the Rent(as % of GDP) of France and Rent(as % of GDP) of Serbia?
Make the answer very short. -0.69. In the year 2002, what is the difference between the Rent(as % of GDP) of Israel and Rent(as % of GDP) of Saudi Arabia?
Provide a short and direct response. -30.3. In the year 2002, what is the difference between the Rent(as % of GDP) in Israel and Rent(as % of GDP) in Serbia?
Your answer should be compact. -0.7. In the year 2002, what is the difference between the Rent(as % of GDP) of Saudi Arabia and Rent(as % of GDP) of Serbia?
Provide a succinct answer. 29.6. In the year 2003, what is the difference between the Rent(as % of GDP) of France and Rent(as % of GDP) of Israel?
Give a very brief answer. 0.01. In the year 2003, what is the difference between the Rent(as % of GDP) of France and Rent(as % of GDP) of Saudi Arabia?
Offer a terse response. -37.11. In the year 2003, what is the difference between the Rent(as % of GDP) of France and Rent(as % of GDP) of Serbia?
Your answer should be very brief. -0.6. In the year 2003, what is the difference between the Rent(as % of GDP) of Israel and Rent(as % of GDP) of Saudi Arabia?
Your answer should be compact. -37.12. In the year 2003, what is the difference between the Rent(as % of GDP) in Israel and Rent(as % of GDP) in Serbia?
Your answer should be compact. -0.61. In the year 2003, what is the difference between the Rent(as % of GDP) in Saudi Arabia and Rent(as % of GDP) in Serbia?
Your answer should be very brief. 36.51. In the year 2004, what is the difference between the Rent(as % of GDP) in France and Rent(as % of GDP) in Israel?
Provide a succinct answer. 0.01. In the year 2004, what is the difference between the Rent(as % of GDP) of France and Rent(as % of GDP) of Saudi Arabia?
Ensure brevity in your answer.  -43.52. In the year 2004, what is the difference between the Rent(as % of GDP) in France and Rent(as % of GDP) in Serbia?
Your response must be concise. -0.59. In the year 2004, what is the difference between the Rent(as % of GDP) of Israel and Rent(as % of GDP) of Saudi Arabia?
Your response must be concise. -43.53. In the year 2004, what is the difference between the Rent(as % of GDP) in Israel and Rent(as % of GDP) in Serbia?
Offer a very short reply. -0.6. In the year 2004, what is the difference between the Rent(as % of GDP) in Saudi Arabia and Rent(as % of GDP) in Serbia?
Provide a succinct answer. 42.93. In the year 2005, what is the difference between the Rent(as % of GDP) in France and Rent(as % of GDP) in Israel?
Ensure brevity in your answer.  0.02. In the year 2005, what is the difference between the Rent(as % of GDP) of France and Rent(as % of GDP) of Saudi Arabia?
Offer a terse response. -51.69. In the year 2005, what is the difference between the Rent(as % of GDP) of France and Rent(as % of GDP) of Serbia?
Make the answer very short. -0.82. In the year 2005, what is the difference between the Rent(as % of GDP) in Israel and Rent(as % of GDP) in Saudi Arabia?
Provide a succinct answer. -51.7. In the year 2005, what is the difference between the Rent(as % of GDP) of Israel and Rent(as % of GDP) of Serbia?
Provide a short and direct response. -0.84. In the year 2005, what is the difference between the Rent(as % of GDP) of Saudi Arabia and Rent(as % of GDP) of Serbia?
Your answer should be compact. 50.87. What is the ratio of the Rent(as % of GDP) of France in 1998 to that in 1999?
Your response must be concise. 0.74. What is the ratio of the Rent(as % of GDP) of Israel in 1998 to that in 1999?
Provide a succinct answer. 0.69. What is the ratio of the Rent(as % of GDP) of Saudi Arabia in 1998 to that in 1999?
Ensure brevity in your answer.  0.85. What is the ratio of the Rent(as % of GDP) of Serbia in 1998 to that in 1999?
Your answer should be very brief. 0.64. What is the ratio of the Rent(as % of GDP) of France in 1998 to that in 2000?
Provide a succinct answer. 0.4. What is the ratio of the Rent(as % of GDP) in Israel in 1998 to that in 2000?
Offer a very short reply. 1.11. What is the ratio of the Rent(as % of GDP) in Saudi Arabia in 1998 to that in 2000?
Your answer should be very brief. 0.55. What is the ratio of the Rent(as % of GDP) in Serbia in 1998 to that in 2000?
Offer a terse response. 0.12. What is the ratio of the Rent(as % of GDP) of France in 1998 to that in 2001?
Your response must be concise. 0.51. What is the ratio of the Rent(as % of GDP) of Israel in 1998 to that in 2001?
Make the answer very short. 1.34. What is the ratio of the Rent(as % of GDP) of Saudi Arabia in 1998 to that in 2001?
Give a very brief answer. 0.66. What is the ratio of the Rent(as % of GDP) in Serbia in 1998 to that in 2001?
Your response must be concise. 0.31. What is the ratio of the Rent(as % of GDP) in France in 1998 to that in 2002?
Offer a very short reply. 0.57. What is the ratio of the Rent(as % of GDP) of Israel in 1998 to that in 2002?
Give a very brief answer. 0.97. What is the ratio of the Rent(as % of GDP) in Saudi Arabia in 1998 to that in 2002?
Give a very brief answer. 0.74. What is the ratio of the Rent(as % of GDP) in Serbia in 1998 to that in 2002?
Ensure brevity in your answer.  0.44. What is the ratio of the Rent(as % of GDP) in France in 1998 to that in 2003?
Make the answer very short. 0.63. What is the ratio of the Rent(as % of GDP) of Israel in 1998 to that in 2003?
Your response must be concise. 1.42. What is the ratio of the Rent(as % of GDP) of Saudi Arabia in 1998 to that in 2003?
Make the answer very short. 0.6. What is the ratio of the Rent(as % of GDP) in Serbia in 1998 to that in 2003?
Make the answer very short. 0.51. What is the ratio of the Rent(as % of GDP) of France in 1998 to that in 2004?
Keep it short and to the point. 0.57. What is the ratio of the Rent(as % of GDP) in Israel in 1998 to that in 2004?
Your answer should be compact. 0.89. What is the ratio of the Rent(as % of GDP) of Saudi Arabia in 1998 to that in 2004?
Keep it short and to the point. 0.51. What is the ratio of the Rent(as % of GDP) in Serbia in 1998 to that in 2004?
Your answer should be compact. 0.51. What is the ratio of the Rent(as % of GDP) in France in 1998 to that in 2005?
Your response must be concise. 0.42. What is the ratio of the Rent(as % of GDP) in Israel in 1998 to that in 2005?
Give a very brief answer. 0.49. What is the ratio of the Rent(as % of GDP) of Saudi Arabia in 1998 to that in 2005?
Make the answer very short. 0.43. What is the ratio of the Rent(as % of GDP) in Serbia in 1998 to that in 2005?
Your answer should be very brief. 0.37. What is the ratio of the Rent(as % of GDP) in France in 1999 to that in 2000?
Your response must be concise. 0.54. What is the ratio of the Rent(as % of GDP) in Israel in 1999 to that in 2000?
Give a very brief answer. 1.6. What is the ratio of the Rent(as % of GDP) of Saudi Arabia in 1999 to that in 2000?
Keep it short and to the point. 0.65. What is the ratio of the Rent(as % of GDP) of Serbia in 1999 to that in 2000?
Offer a terse response. 0.19. What is the ratio of the Rent(as % of GDP) of France in 1999 to that in 2001?
Keep it short and to the point. 0.69. What is the ratio of the Rent(as % of GDP) of Israel in 1999 to that in 2001?
Provide a succinct answer. 1.92. What is the ratio of the Rent(as % of GDP) in Saudi Arabia in 1999 to that in 2001?
Your answer should be compact. 0.78. What is the ratio of the Rent(as % of GDP) in Serbia in 1999 to that in 2001?
Ensure brevity in your answer.  0.48. What is the ratio of the Rent(as % of GDP) of France in 1999 to that in 2002?
Offer a terse response. 0.77. What is the ratio of the Rent(as % of GDP) in Israel in 1999 to that in 2002?
Offer a very short reply. 1.39. What is the ratio of the Rent(as % of GDP) of Saudi Arabia in 1999 to that in 2002?
Offer a terse response. 0.87. What is the ratio of the Rent(as % of GDP) in Serbia in 1999 to that in 2002?
Your answer should be compact. 0.68. What is the ratio of the Rent(as % of GDP) in France in 1999 to that in 2003?
Give a very brief answer. 0.85. What is the ratio of the Rent(as % of GDP) of Israel in 1999 to that in 2003?
Your answer should be compact. 2.04. What is the ratio of the Rent(as % of GDP) in Saudi Arabia in 1999 to that in 2003?
Ensure brevity in your answer.  0.71. What is the ratio of the Rent(as % of GDP) of Serbia in 1999 to that in 2003?
Provide a succinct answer. 0.79. What is the ratio of the Rent(as % of GDP) in France in 1999 to that in 2004?
Provide a short and direct response. 0.76. What is the ratio of the Rent(as % of GDP) in Israel in 1999 to that in 2004?
Give a very brief answer. 1.29. What is the ratio of the Rent(as % of GDP) of Saudi Arabia in 1999 to that in 2004?
Offer a terse response. 0.6. What is the ratio of the Rent(as % of GDP) of Serbia in 1999 to that in 2004?
Provide a succinct answer. 0.8. What is the ratio of the Rent(as % of GDP) in France in 1999 to that in 2005?
Provide a succinct answer. 0.57. What is the ratio of the Rent(as % of GDP) of Israel in 1999 to that in 2005?
Provide a short and direct response. 0.7. What is the ratio of the Rent(as % of GDP) in Saudi Arabia in 1999 to that in 2005?
Give a very brief answer. 0.51. What is the ratio of the Rent(as % of GDP) in Serbia in 1999 to that in 2005?
Provide a short and direct response. 0.58. What is the ratio of the Rent(as % of GDP) in France in 2000 to that in 2001?
Keep it short and to the point. 1.28. What is the ratio of the Rent(as % of GDP) of Israel in 2000 to that in 2001?
Your response must be concise. 1.2. What is the ratio of the Rent(as % of GDP) of Saudi Arabia in 2000 to that in 2001?
Your answer should be compact. 1.19. What is the ratio of the Rent(as % of GDP) in Serbia in 2000 to that in 2001?
Keep it short and to the point. 2.52. What is the ratio of the Rent(as % of GDP) in France in 2000 to that in 2002?
Your response must be concise. 1.43. What is the ratio of the Rent(as % of GDP) of Israel in 2000 to that in 2002?
Offer a very short reply. 0.87. What is the ratio of the Rent(as % of GDP) in Saudi Arabia in 2000 to that in 2002?
Give a very brief answer. 1.33. What is the ratio of the Rent(as % of GDP) of Serbia in 2000 to that in 2002?
Provide a short and direct response. 3.59. What is the ratio of the Rent(as % of GDP) of France in 2000 to that in 2003?
Your answer should be compact. 1.58. What is the ratio of the Rent(as % of GDP) in Israel in 2000 to that in 2003?
Provide a succinct answer. 1.28. What is the ratio of the Rent(as % of GDP) of Saudi Arabia in 2000 to that in 2003?
Ensure brevity in your answer.  1.08. What is the ratio of the Rent(as % of GDP) of Serbia in 2000 to that in 2003?
Your answer should be very brief. 4.13. What is the ratio of the Rent(as % of GDP) of France in 2000 to that in 2004?
Keep it short and to the point. 1.42. What is the ratio of the Rent(as % of GDP) of Israel in 2000 to that in 2004?
Provide a short and direct response. 0.8. What is the ratio of the Rent(as % of GDP) of Saudi Arabia in 2000 to that in 2004?
Keep it short and to the point. 0.93. What is the ratio of the Rent(as % of GDP) in Serbia in 2000 to that in 2004?
Give a very brief answer. 4.19. What is the ratio of the Rent(as % of GDP) in France in 2000 to that in 2005?
Offer a very short reply. 1.06. What is the ratio of the Rent(as % of GDP) of Israel in 2000 to that in 2005?
Keep it short and to the point. 0.44. What is the ratio of the Rent(as % of GDP) in Saudi Arabia in 2000 to that in 2005?
Ensure brevity in your answer.  0.78. What is the ratio of the Rent(as % of GDP) in Serbia in 2000 to that in 2005?
Make the answer very short. 3.02. What is the ratio of the Rent(as % of GDP) of France in 2001 to that in 2002?
Keep it short and to the point. 1.12. What is the ratio of the Rent(as % of GDP) in Israel in 2001 to that in 2002?
Give a very brief answer. 0.72. What is the ratio of the Rent(as % of GDP) in Saudi Arabia in 2001 to that in 2002?
Provide a succinct answer. 1.11. What is the ratio of the Rent(as % of GDP) of Serbia in 2001 to that in 2002?
Ensure brevity in your answer.  1.43. What is the ratio of the Rent(as % of GDP) in France in 2001 to that in 2003?
Give a very brief answer. 1.24. What is the ratio of the Rent(as % of GDP) of Israel in 2001 to that in 2003?
Provide a succinct answer. 1.06. What is the ratio of the Rent(as % of GDP) of Saudi Arabia in 2001 to that in 2003?
Provide a short and direct response. 0.91. What is the ratio of the Rent(as % of GDP) of Serbia in 2001 to that in 2003?
Your answer should be compact. 1.64. What is the ratio of the Rent(as % of GDP) of France in 2001 to that in 2004?
Your answer should be compact. 1.11. What is the ratio of the Rent(as % of GDP) in Israel in 2001 to that in 2004?
Your response must be concise. 0.67. What is the ratio of the Rent(as % of GDP) in Saudi Arabia in 2001 to that in 2004?
Offer a very short reply. 0.77. What is the ratio of the Rent(as % of GDP) of Serbia in 2001 to that in 2004?
Offer a terse response. 1.66. What is the ratio of the Rent(as % of GDP) of France in 2001 to that in 2005?
Your answer should be very brief. 0.83. What is the ratio of the Rent(as % of GDP) in Israel in 2001 to that in 2005?
Ensure brevity in your answer.  0.36. What is the ratio of the Rent(as % of GDP) in Saudi Arabia in 2001 to that in 2005?
Ensure brevity in your answer.  0.65. What is the ratio of the Rent(as % of GDP) of Serbia in 2001 to that in 2005?
Provide a succinct answer. 1.2. What is the ratio of the Rent(as % of GDP) in France in 2002 to that in 2003?
Offer a very short reply. 1.11. What is the ratio of the Rent(as % of GDP) of Israel in 2002 to that in 2003?
Your answer should be compact. 1.47. What is the ratio of the Rent(as % of GDP) of Saudi Arabia in 2002 to that in 2003?
Your answer should be compact. 0.82. What is the ratio of the Rent(as % of GDP) of Serbia in 2002 to that in 2003?
Keep it short and to the point. 1.15. What is the ratio of the Rent(as % of GDP) of France in 2002 to that in 2004?
Your response must be concise. 0.99. What is the ratio of the Rent(as % of GDP) of Israel in 2002 to that in 2004?
Give a very brief answer. 0.92. What is the ratio of the Rent(as % of GDP) of Saudi Arabia in 2002 to that in 2004?
Provide a succinct answer. 0.7. What is the ratio of the Rent(as % of GDP) in Serbia in 2002 to that in 2004?
Your answer should be compact. 1.17. What is the ratio of the Rent(as % of GDP) in France in 2002 to that in 2005?
Offer a terse response. 0.74. What is the ratio of the Rent(as % of GDP) of Israel in 2002 to that in 2005?
Your response must be concise. 0.5. What is the ratio of the Rent(as % of GDP) in Saudi Arabia in 2002 to that in 2005?
Your response must be concise. 0.59. What is the ratio of the Rent(as % of GDP) in Serbia in 2002 to that in 2005?
Provide a succinct answer. 0.84. What is the ratio of the Rent(as % of GDP) of France in 2003 to that in 2004?
Keep it short and to the point. 0.9. What is the ratio of the Rent(as % of GDP) in Israel in 2003 to that in 2004?
Provide a short and direct response. 0.63. What is the ratio of the Rent(as % of GDP) in Saudi Arabia in 2003 to that in 2004?
Make the answer very short. 0.85. What is the ratio of the Rent(as % of GDP) of Serbia in 2003 to that in 2004?
Provide a succinct answer. 1.01. What is the ratio of the Rent(as % of GDP) of France in 2003 to that in 2005?
Make the answer very short. 0.67. What is the ratio of the Rent(as % of GDP) in Israel in 2003 to that in 2005?
Make the answer very short. 0.34. What is the ratio of the Rent(as % of GDP) in Saudi Arabia in 2003 to that in 2005?
Offer a very short reply. 0.72. What is the ratio of the Rent(as % of GDP) in Serbia in 2003 to that in 2005?
Offer a terse response. 0.73. What is the ratio of the Rent(as % of GDP) in France in 2004 to that in 2005?
Offer a very short reply. 0.74. What is the ratio of the Rent(as % of GDP) in Israel in 2004 to that in 2005?
Make the answer very short. 0.54. What is the ratio of the Rent(as % of GDP) of Saudi Arabia in 2004 to that in 2005?
Offer a very short reply. 0.84. What is the ratio of the Rent(as % of GDP) of Serbia in 2004 to that in 2005?
Your answer should be very brief. 0.72. What is the difference between the highest and the second highest Rent(as % of GDP) in France?
Provide a succinct answer. 0. What is the difference between the highest and the second highest Rent(as % of GDP) of Saudi Arabia?
Offer a terse response. 8.17. What is the difference between the highest and the second highest Rent(as % of GDP) in Serbia?
Provide a short and direct response. 1.52. What is the difference between the highest and the lowest Rent(as % of GDP) in France?
Make the answer very short. 0.01. What is the difference between the highest and the lowest Rent(as % of GDP) in Israel?
Offer a terse response. 0. What is the difference between the highest and the lowest Rent(as % of GDP) of Saudi Arabia?
Offer a terse response. 29.4. What is the difference between the highest and the lowest Rent(as % of GDP) in Serbia?
Your answer should be very brief. 2.22. 